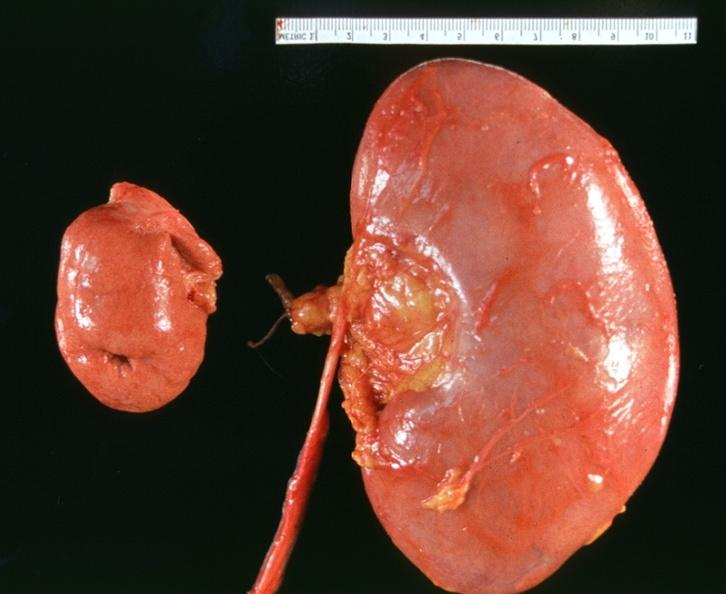where is this?
Answer the question using a single word or phrase. Urinary 